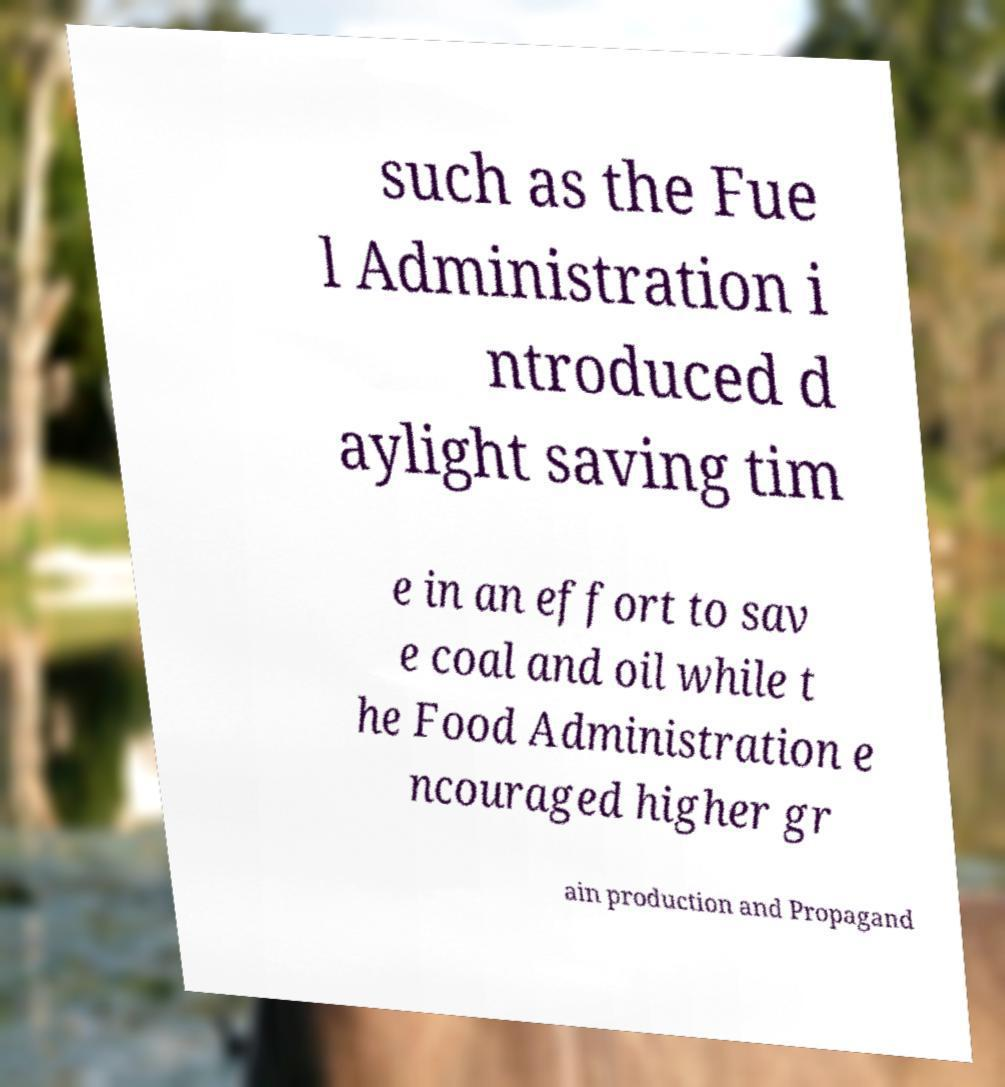Please read and relay the text visible in this image. What does it say? such as the Fue l Administration i ntroduced d aylight saving tim e in an effort to sav e coal and oil while t he Food Administration e ncouraged higher gr ain production and Propagand 